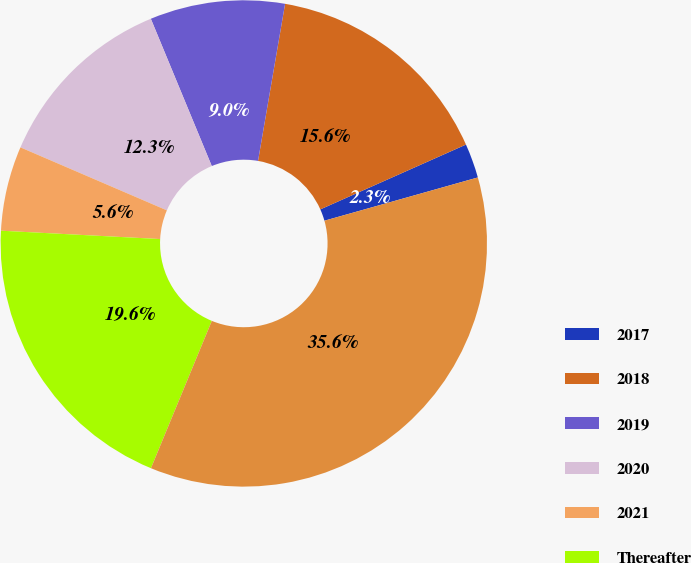Convert chart to OTSL. <chart><loc_0><loc_0><loc_500><loc_500><pie_chart><fcel>2017<fcel>2018<fcel>2019<fcel>2020<fcel>2021<fcel>Thereafter<fcel>Total<nl><fcel>2.29%<fcel>15.62%<fcel>8.96%<fcel>12.29%<fcel>5.63%<fcel>19.6%<fcel>35.61%<nl></chart> 